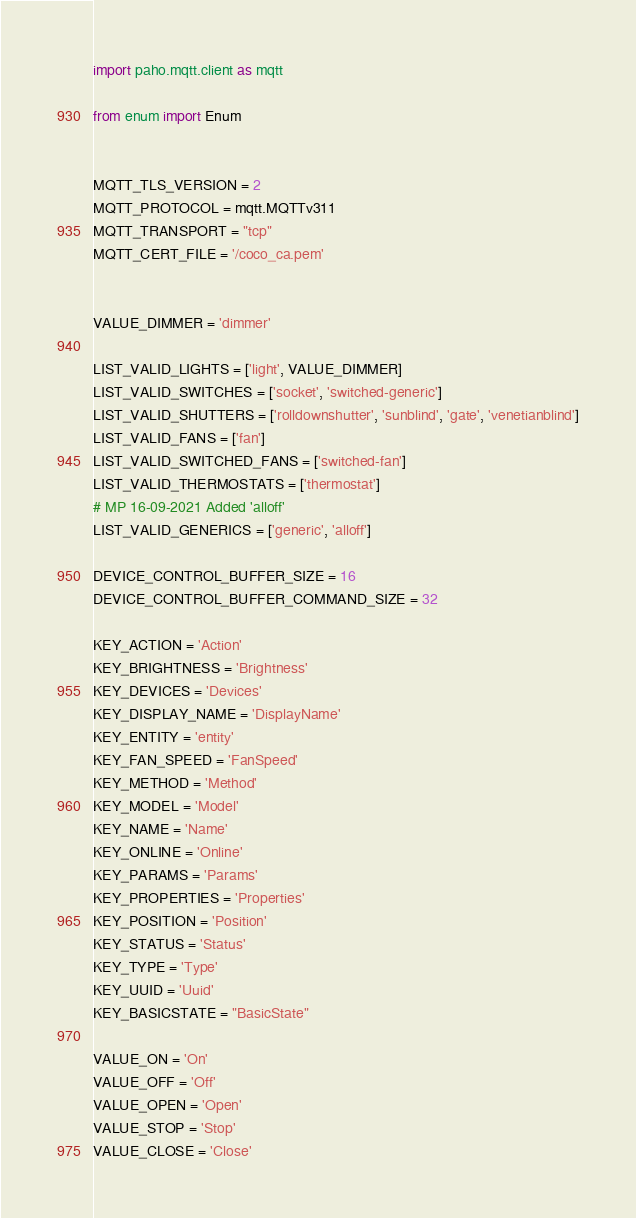<code> <loc_0><loc_0><loc_500><loc_500><_Python_>import paho.mqtt.client as mqtt

from enum import Enum


MQTT_TLS_VERSION = 2
MQTT_PROTOCOL = mqtt.MQTTv311
MQTT_TRANSPORT = "tcp"
MQTT_CERT_FILE = '/coco_ca.pem'


VALUE_DIMMER = 'dimmer'

LIST_VALID_LIGHTS = ['light', VALUE_DIMMER]
LIST_VALID_SWITCHES = ['socket', 'switched-generic']
LIST_VALID_SHUTTERS = ['rolldownshutter', 'sunblind', 'gate', 'venetianblind']
LIST_VALID_FANS = ['fan']
LIST_VALID_SWITCHED_FANS = ['switched-fan']
LIST_VALID_THERMOSTATS = ['thermostat']
# MP 16-09-2021 Added 'alloff'
LIST_VALID_GENERICS = ['generic', 'alloff']

DEVICE_CONTROL_BUFFER_SIZE = 16
DEVICE_CONTROL_BUFFER_COMMAND_SIZE = 32

KEY_ACTION = 'Action'
KEY_BRIGHTNESS = 'Brightness'
KEY_DEVICES = 'Devices'
KEY_DISPLAY_NAME = 'DisplayName'
KEY_ENTITY = 'entity'
KEY_FAN_SPEED = 'FanSpeed'
KEY_METHOD = 'Method'
KEY_MODEL = 'Model'
KEY_NAME = 'Name'
KEY_ONLINE = 'Online'
KEY_PARAMS = 'Params'
KEY_PROPERTIES = 'Properties'
KEY_POSITION = 'Position'
KEY_STATUS = 'Status'
KEY_TYPE = 'Type'
KEY_UUID = 'Uuid'
KEY_BASICSTATE = "BasicState"

VALUE_ON = 'On'
VALUE_OFF = 'Off'
VALUE_OPEN = 'Open'
VALUE_STOP = 'Stop'
VALUE_CLOSE = 'Close'</code> 